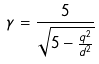<formula> <loc_0><loc_0><loc_500><loc_500>\gamma = \frac { 5 } { \sqrt { 5 - \frac { q ^ { 2 } } { d ^ { 2 } } } }</formula> 